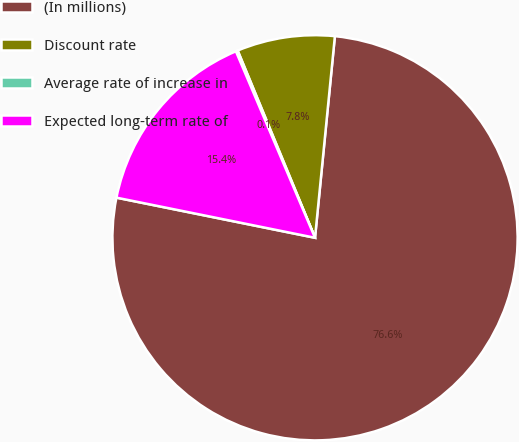Convert chart to OTSL. <chart><loc_0><loc_0><loc_500><loc_500><pie_chart><fcel>(In millions)<fcel>Discount rate<fcel>Average rate of increase in<fcel>Expected long-term rate of<nl><fcel>76.61%<fcel>7.8%<fcel>0.15%<fcel>15.44%<nl></chart> 